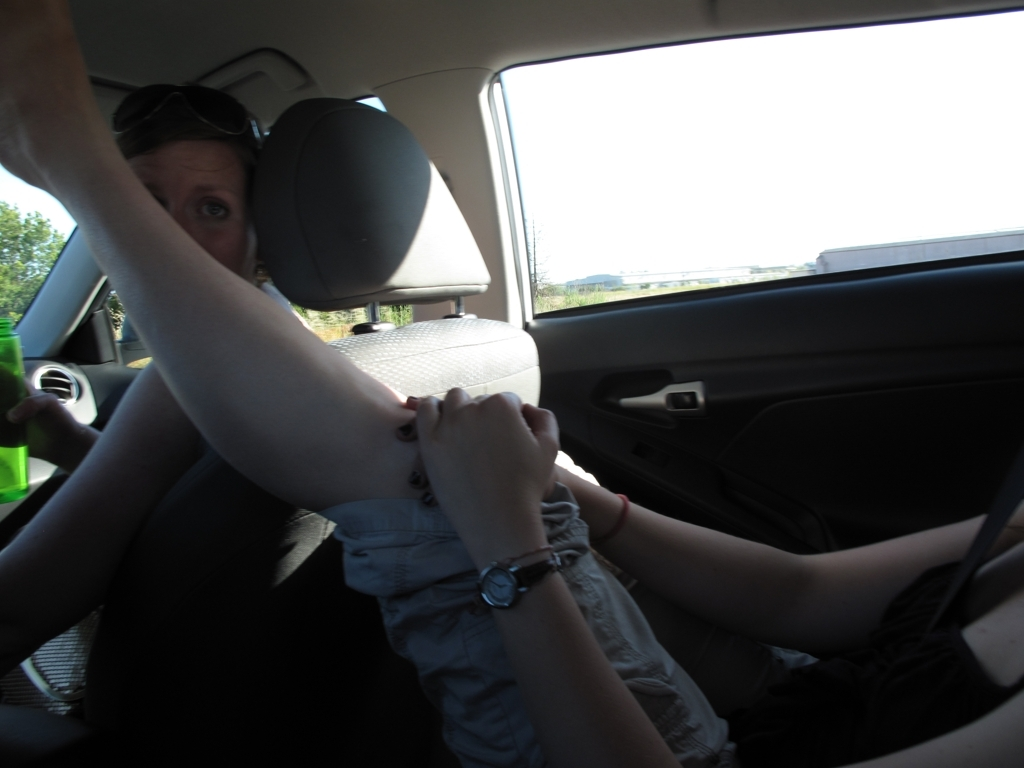What can we infer about the person taking the photo? The photographer seems to be situated on the passenger side and likely took the photo spontaneously, perhaps to capture a moment of interaction or an amusing expression, without focusing on technical aspects like composition and focus. 